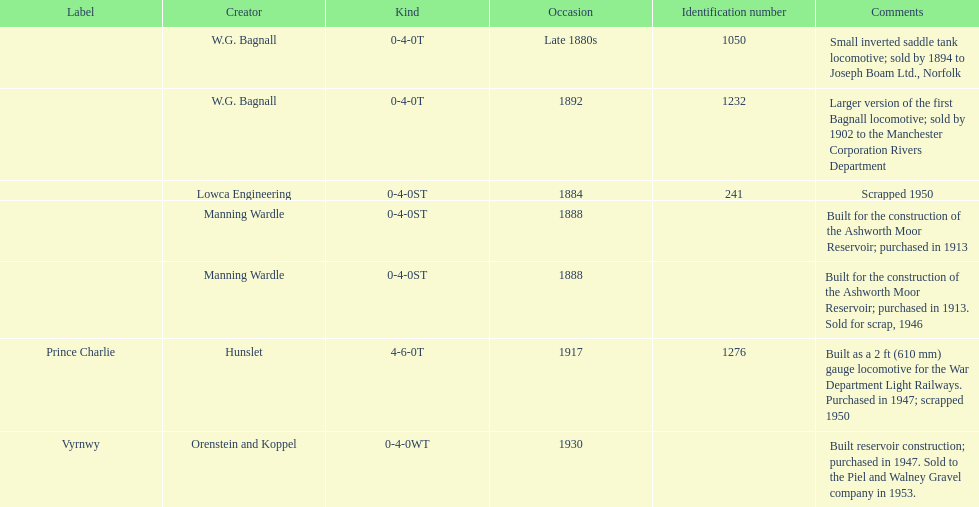Which locomotive builder built a locomotive after 1888 and built the locomotive as a 2ft gauge locomotive? Hunslet. 